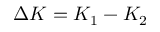Convert formula to latex. <formula><loc_0><loc_0><loc_500><loc_500>\Delta K = K _ { 1 } - K _ { 2 }</formula> 